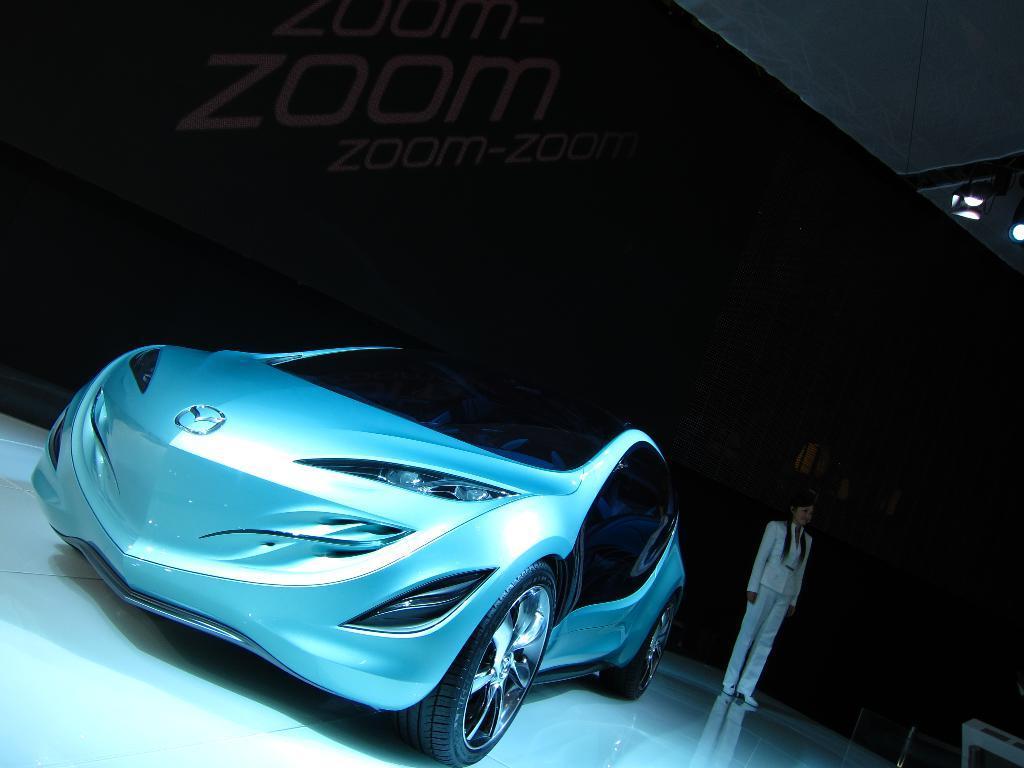Can you describe this image briefly? In this image, I can see a car. Here is a person standing. In the background, that looks like a hoarding with the letters on it. On the right side of the image, I can see the show lights. This is a floor. 